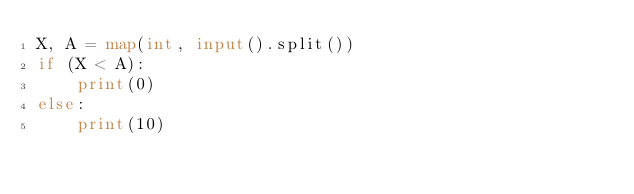<code> <loc_0><loc_0><loc_500><loc_500><_Python_>X, A = map(int, input().split())
if (X < A):
    print(0)
else:
    print(10)
</code> 